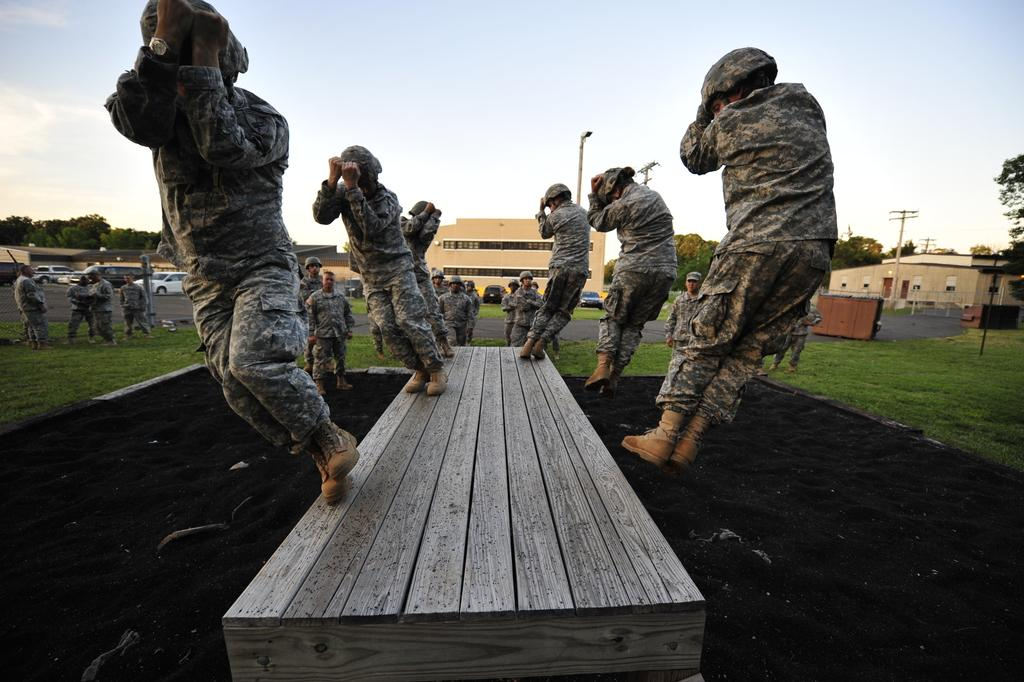What can be seen in the image? There are people standing in the image, wearing caps. What else is visible in the image? There are buildings, trees, grass on the ground, poles, and parked cars in the image. How is the sky depicted in the image? The sky is cloudy in the image. What type of meat is being grilled in the image? There is no meat or grilling activity present in the image. How many houses are visible in the image? The image does not show any houses; it features people, buildings, trees, grass, poles, and parked cars. 